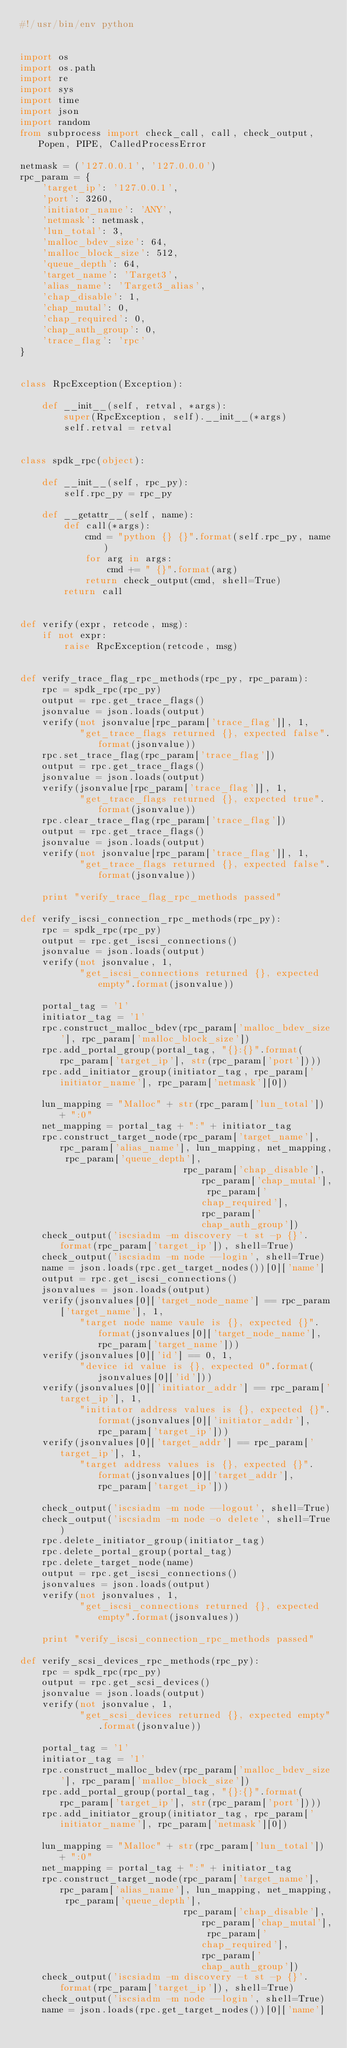Convert code to text. <code><loc_0><loc_0><loc_500><loc_500><_Python_>#!/usr/bin/env python


import os
import os.path
import re
import sys
import time
import json
import random
from subprocess import check_call, call, check_output, Popen, PIPE, CalledProcessError

netmask = ('127.0.0.1', '127.0.0.0')
rpc_param = {
    'target_ip': '127.0.0.1',
    'port': 3260,
    'initiator_name': 'ANY',
    'netmask': netmask,
    'lun_total': 3,
    'malloc_bdev_size': 64,
    'malloc_block_size': 512,
    'queue_depth': 64,
    'target_name': 'Target3',
    'alias_name': 'Target3_alias',
    'chap_disable': 1,
    'chap_mutal': 0,
    'chap_required': 0,
    'chap_auth_group': 0,
    'trace_flag': 'rpc'
}


class RpcException(Exception):

    def __init__(self, retval, *args):
        super(RpcException, self).__init__(*args)
        self.retval = retval


class spdk_rpc(object):

    def __init__(self, rpc_py):
        self.rpc_py = rpc_py

    def __getattr__(self, name):
        def call(*args):
            cmd = "python {} {}".format(self.rpc_py, name)
            for arg in args:
                cmd += " {}".format(arg)
            return check_output(cmd, shell=True)
        return call


def verify(expr, retcode, msg):
    if not expr:
        raise RpcException(retcode, msg)


def verify_trace_flag_rpc_methods(rpc_py, rpc_param):
    rpc = spdk_rpc(rpc_py)
    output = rpc.get_trace_flags()
    jsonvalue = json.loads(output)
    verify(not jsonvalue[rpc_param['trace_flag']], 1,
           "get_trace_flags returned {}, expected false".format(jsonvalue))
    rpc.set_trace_flag(rpc_param['trace_flag'])
    output = rpc.get_trace_flags()
    jsonvalue = json.loads(output)
    verify(jsonvalue[rpc_param['trace_flag']], 1,
           "get_trace_flags returned {}, expected true".format(jsonvalue))
    rpc.clear_trace_flag(rpc_param['trace_flag'])
    output = rpc.get_trace_flags()
    jsonvalue = json.loads(output)
    verify(not jsonvalue[rpc_param['trace_flag']], 1,
           "get_trace_flags returned {}, expected false".format(jsonvalue))

    print "verify_trace_flag_rpc_methods passed"

def verify_iscsi_connection_rpc_methods(rpc_py):
    rpc = spdk_rpc(rpc_py)
    output = rpc.get_iscsi_connections()
    jsonvalue = json.loads(output)
    verify(not jsonvalue, 1,
           "get_iscsi_connections returned {}, expected empty".format(jsonvalue))

    portal_tag = '1'
    initiator_tag = '1'
    rpc.construct_malloc_bdev(rpc_param['malloc_bdev_size'], rpc_param['malloc_block_size'])
    rpc.add_portal_group(portal_tag, "{}:{}".format(rpc_param['target_ip'], str(rpc_param['port'])))
    rpc.add_initiator_group(initiator_tag, rpc_param['initiator_name'], rpc_param['netmask'][0])

    lun_mapping = "Malloc" + str(rpc_param['lun_total']) + ":0"
    net_mapping = portal_tag + ":" + initiator_tag
    rpc.construct_target_node(rpc_param['target_name'], rpc_param['alias_name'], lun_mapping, net_mapping, rpc_param['queue_depth'],
                              rpc_param['chap_disable'], rpc_param['chap_mutal'], rpc_param['chap_required'], rpc_param['chap_auth_group'])
    check_output('iscsiadm -m discovery -t st -p {}'.format(rpc_param['target_ip']), shell=True)
    check_output('iscsiadm -m node --login', shell=True)
    name = json.loads(rpc.get_target_nodes())[0]['name']
    output = rpc.get_iscsi_connections()
    jsonvalues = json.loads(output)
    verify(jsonvalues[0]['target_node_name'] == rpc_param['target_name'], 1,
           "target node name vaule is {}, expected {}".format(jsonvalues[0]['target_node_name'], rpc_param['target_name']))
    verify(jsonvalues[0]['id'] == 0, 1,
           "device id value is {}, expected 0".format(jsonvalues[0]['id']))
    verify(jsonvalues[0]['initiator_addr'] == rpc_param['target_ip'], 1,
           "initiator address values is {}, expected {}".format(jsonvalues[0]['initiator_addr'], rpc_param['target_ip']))
    verify(jsonvalues[0]['target_addr'] == rpc_param['target_ip'], 1,
           "target address values is {}, expected {}".format(jsonvalues[0]['target_addr'], rpc_param['target_ip']))

    check_output('iscsiadm -m node --logout', shell=True)
    check_output('iscsiadm -m node -o delete', shell=True)
    rpc.delete_initiator_group(initiator_tag)
    rpc.delete_portal_group(portal_tag)
    rpc.delete_target_node(name)
    output = rpc.get_iscsi_connections()
    jsonvalues = json.loads(output)
    verify(not jsonvalues, 1,
           "get_iscsi_connections returned {}, expected empty".format(jsonvalues))

    print "verify_iscsi_connection_rpc_methods passed"

def verify_scsi_devices_rpc_methods(rpc_py):
    rpc = spdk_rpc(rpc_py)
    output = rpc.get_scsi_devices()
    jsonvalue = json.loads(output)
    verify(not jsonvalue, 1,
           "get_scsi_devices returned {}, expected empty".format(jsonvalue))

    portal_tag = '1'
    initiator_tag = '1'
    rpc.construct_malloc_bdev(rpc_param['malloc_bdev_size'], rpc_param['malloc_block_size'])
    rpc.add_portal_group(portal_tag, "{}:{}".format(rpc_param['target_ip'], str(rpc_param['port'])))
    rpc.add_initiator_group(initiator_tag, rpc_param['initiator_name'], rpc_param['netmask'][0])

    lun_mapping = "Malloc" + str(rpc_param['lun_total']) + ":0"
    net_mapping = portal_tag + ":" + initiator_tag
    rpc.construct_target_node(rpc_param['target_name'], rpc_param['alias_name'], lun_mapping, net_mapping, rpc_param['queue_depth'],
                              rpc_param['chap_disable'], rpc_param['chap_mutal'], rpc_param['chap_required'], rpc_param['chap_auth_group'])
    check_output('iscsiadm -m discovery -t st -p {}'.format(rpc_param['target_ip']), shell=True)
    check_output('iscsiadm -m node --login', shell=True)
    name = json.loads(rpc.get_target_nodes())[0]['name']</code> 